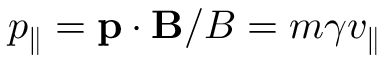Convert formula to latex. <formula><loc_0><loc_0><loc_500><loc_500>p _ { \| } = p \cdot B / B = m \gamma v _ { \| }</formula> 